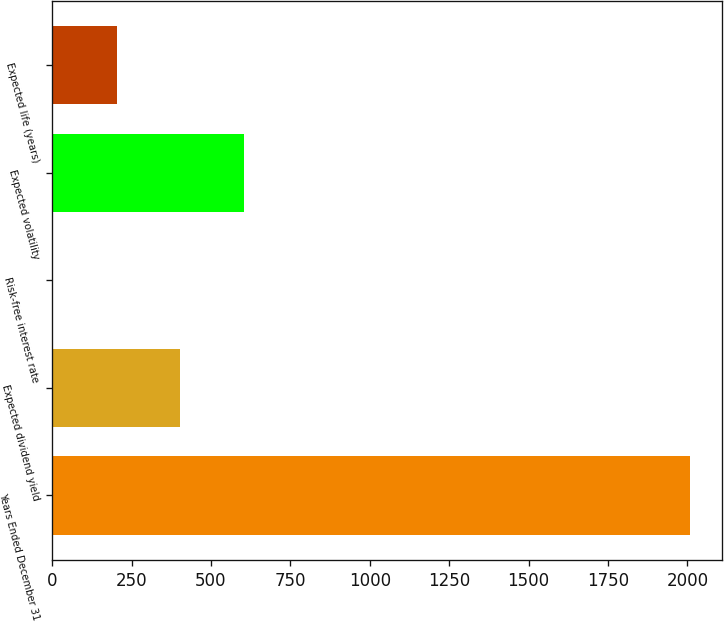Convert chart to OTSL. <chart><loc_0><loc_0><loc_500><loc_500><bar_chart><fcel>Years Ended December 31<fcel>Expected dividend yield<fcel>Risk-free interest rate<fcel>Expected volatility<fcel>Expected life (years)<nl><fcel>2009<fcel>403.56<fcel>2.2<fcel>604.24<fcel>202.88<nl></chart> 